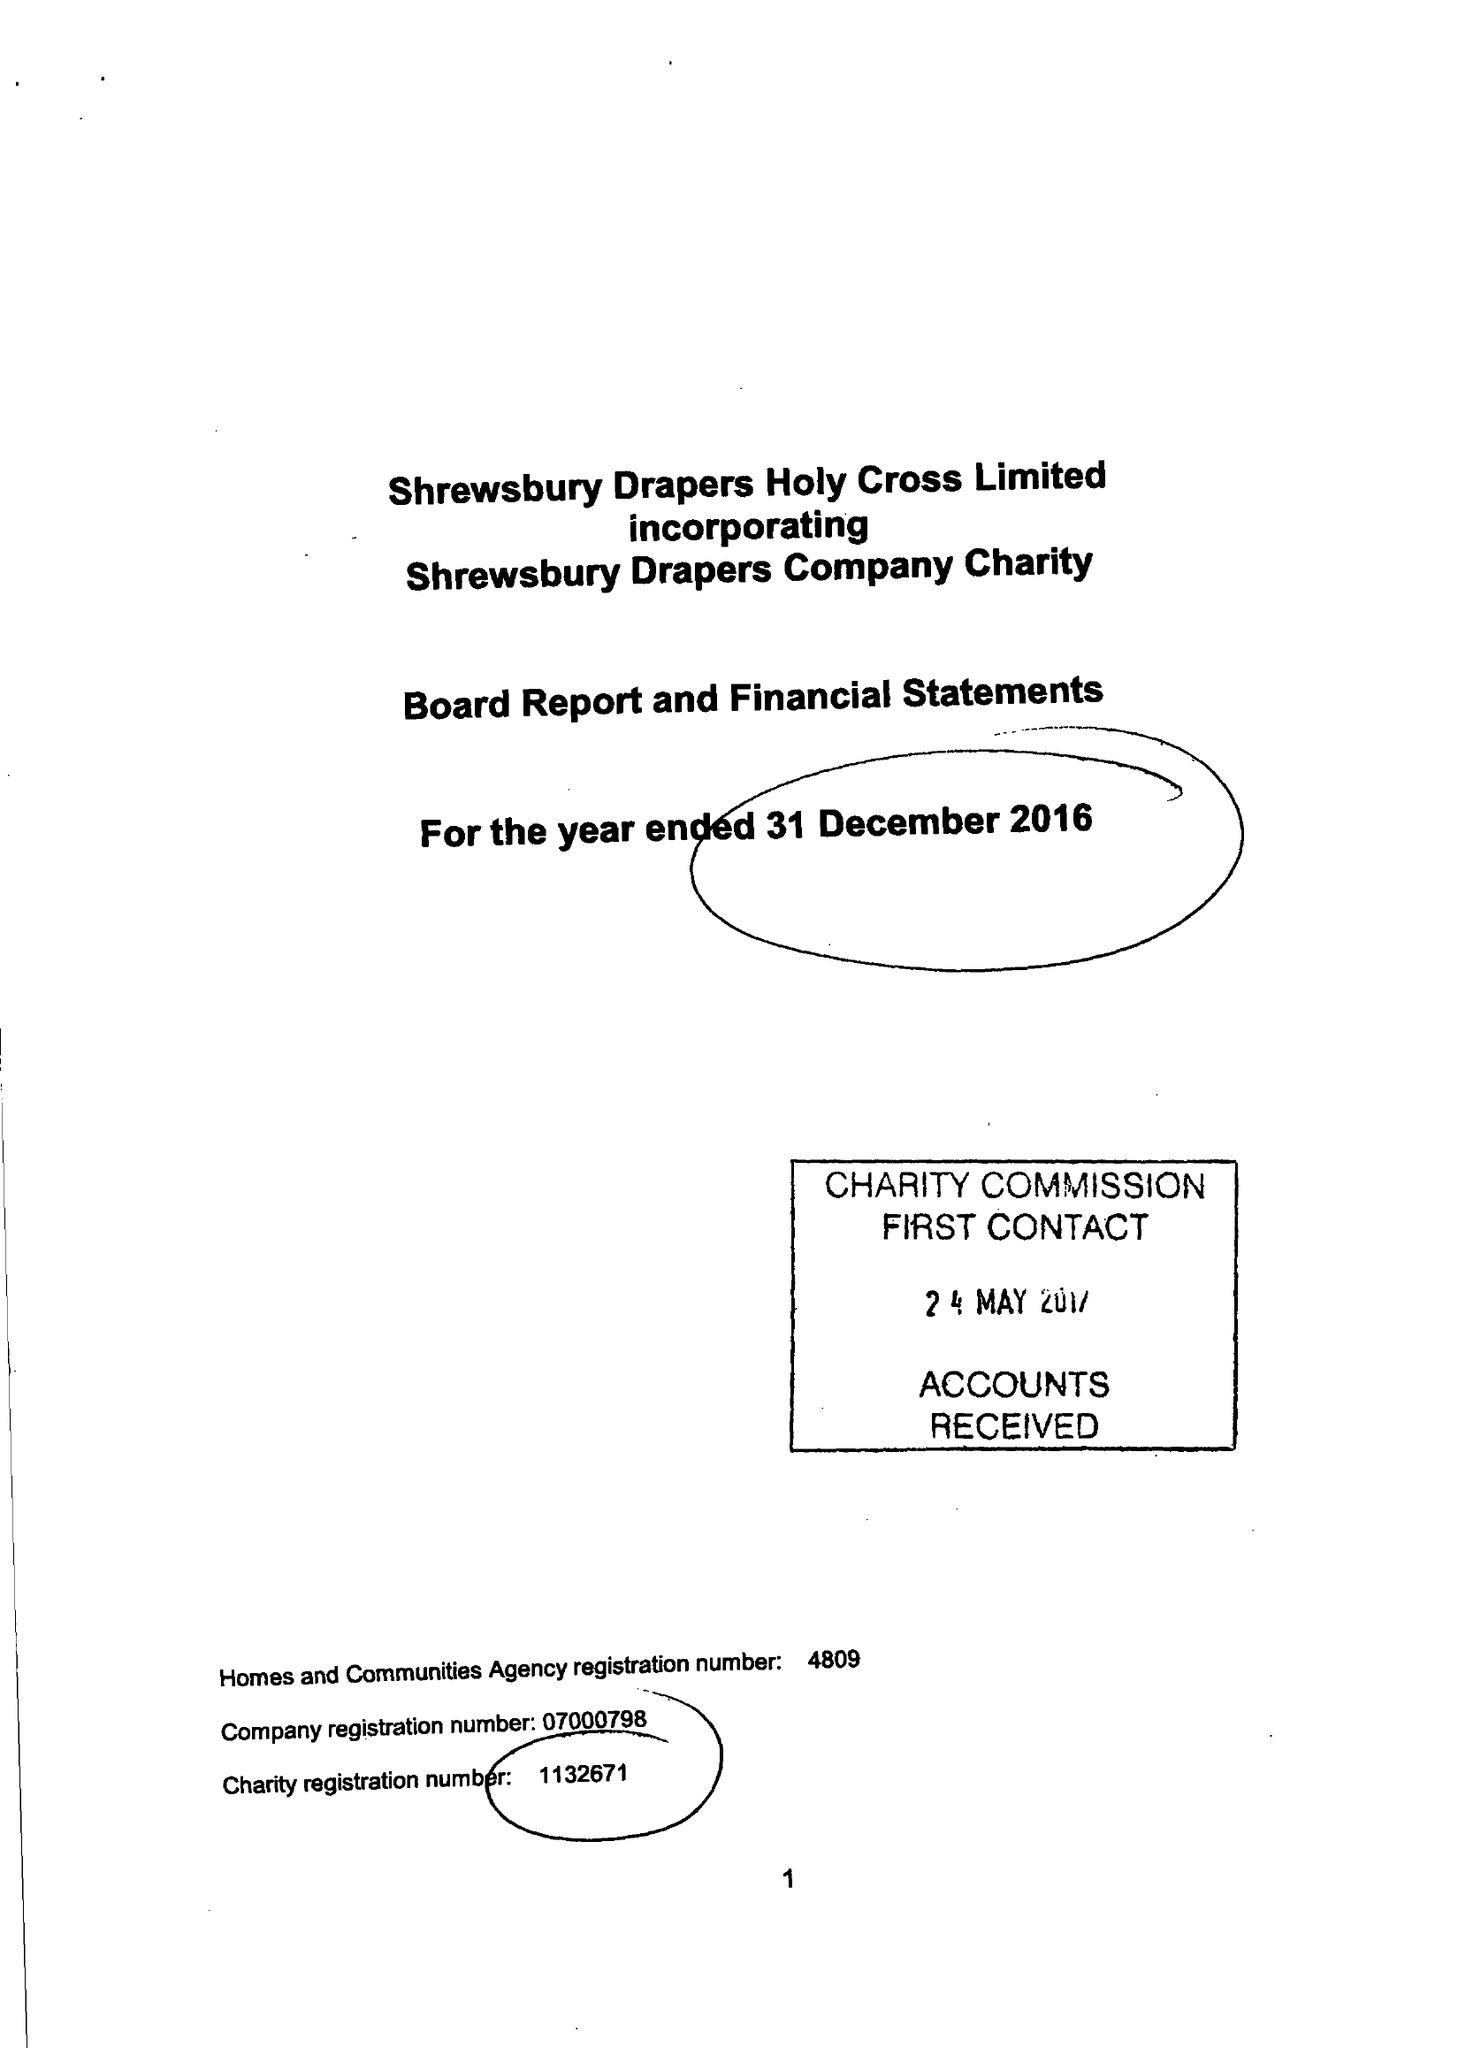What is the value for the address__street_line?
Answer the question using a single word or phrase. None 